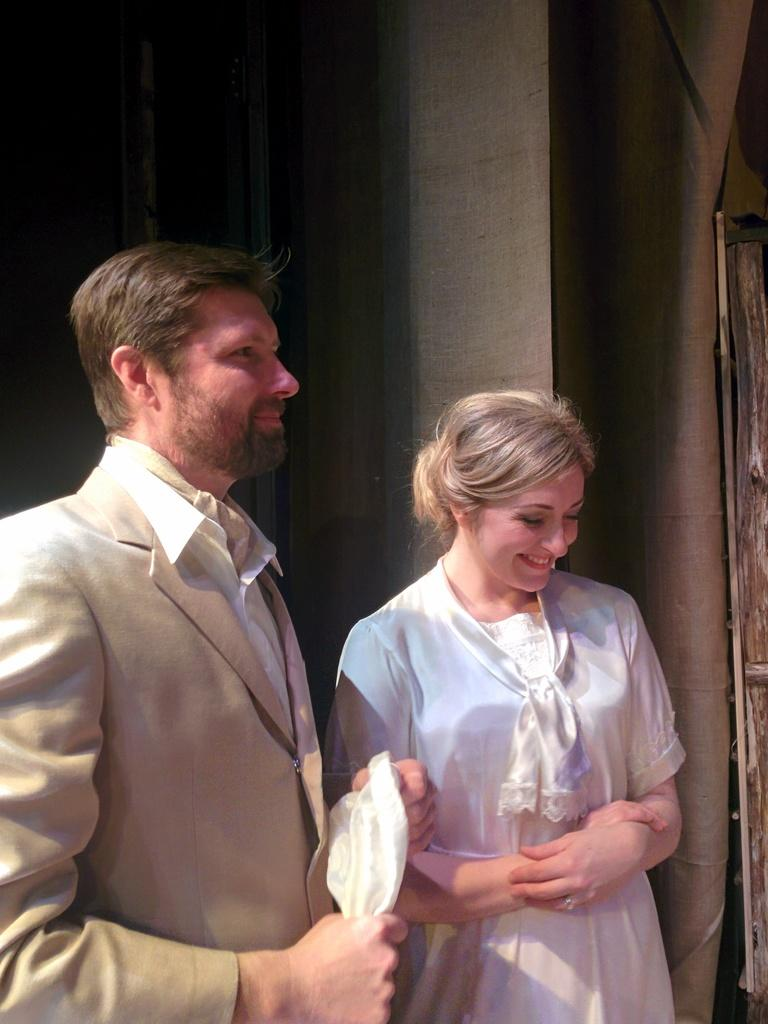How many people are in the image? There are two persons standing in the center of the image. What are the expressions on the faces of the people in the image? The two persons are smiling. What can be seen in the background of the image? There is a wall visible in the background of the image. What year is depicted in the image? The image does not depict a specific year; it is a photograph of two people smiling. Can you see a match being lit in the image? There is no match or any indication of fire in the image. 